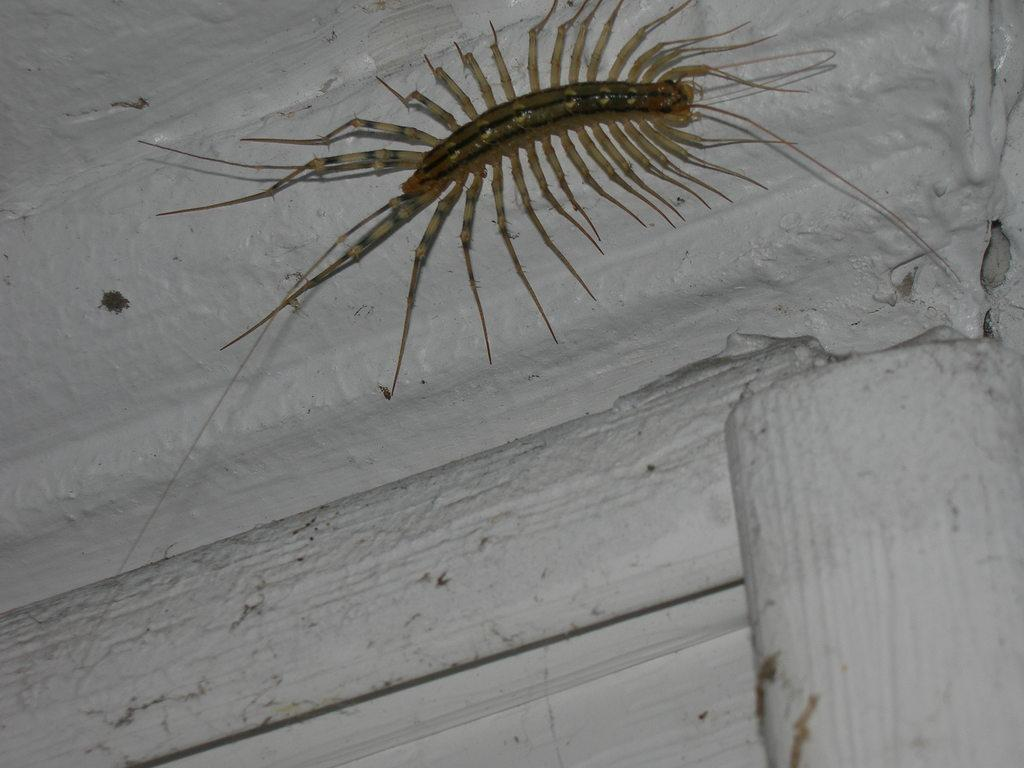What type of creature is in the image? There is an insect in the image. Where is the insect located? The insect is on a wall. How does the insect interact with the sack in the image? There is no sack present in the image, so the insect cannot interact with it. 